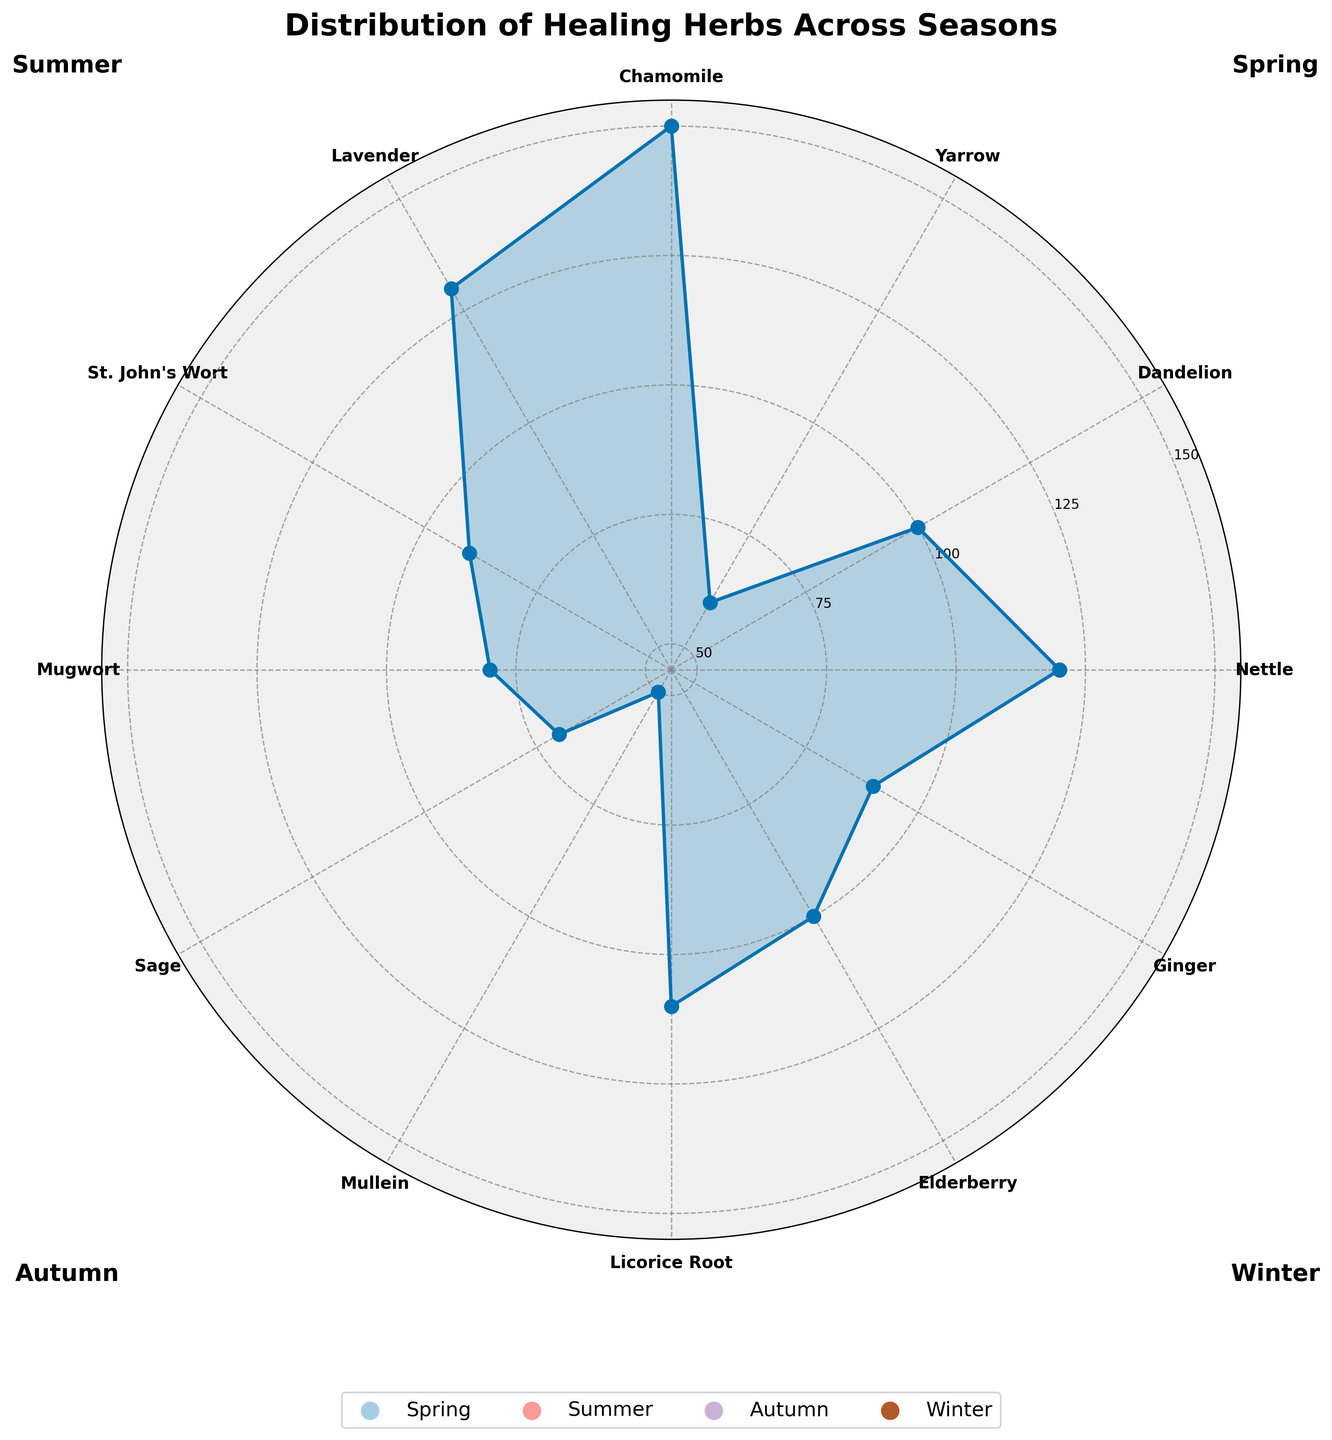What is the title of the chart? The title of the chart is displayed at the top of the rose chart. It provides a summary of what the chart represents.
Answer: "Distribution of Healing Herbs Across Seasons" Which herb is used the most during the summer season? Look at the herb labels and quantities corresponding to the summer season in the polar plot. The highest value for summer is associated with Chamomile.
Answer: Chamomile What are the quantities of Nettle and Yarrow, and what is their sum? Locate Nettle and Yarrow in the spring section and sum their quantities: Nettle (120) + Yarrow (60).
Answer: 180 Which season has the highest total quantity of herbs used? Sum the quantities of herbs in each season: Spring (120+100+60), Summer (150+130+90), Autumn (80+70+50), Winter (110+100+90). Compare the sums.
Answer: Summer Compare the use of Elderberry and Ginger in the winter season. Which one is used more and by how much? Identify the values of Elderberry (100) and Ginger (90) in the winter section. Subtract the smaller quantity from the larger one.
Answer: Elderberry by 10 What is the average quantity of herbs used in the autumn season? Autumn herbs are Mugwort, Sage, and Mullein with quantities of 80, 70, and 50 respectively. Calculate the average: (80 + 70 + 50) / 3.
Answer: 66.67 Rank the seasons from the one with the least herb usage to the one with the most. Sum the quantities for each season and sort them: Spring (280), Summer (370), Autumn (200), Winter (300).
Answer: Autumn < Spring < Winter < Summer What is the median value of herb quantities in the winter season? List the quantities in the winter season: Licorice Root (110), Elderberry (100), Ginger (90). Since there are three values, the median is the second highest value.
Answer: 100 Identify all the winter herbs and their respective quantities. Observe the labels and values in the winter section: Licorice Root (110), Elderberry (100), Ginger (90).
Answer: Licorice Root: 110, Elderberry: 100, Ginger: 90 How many herbs are used in total across all seasons? Sum the quantities of all herbs: 120+100+60+150+130+90+80+70+50+110+100+90.
Answer: 1150 